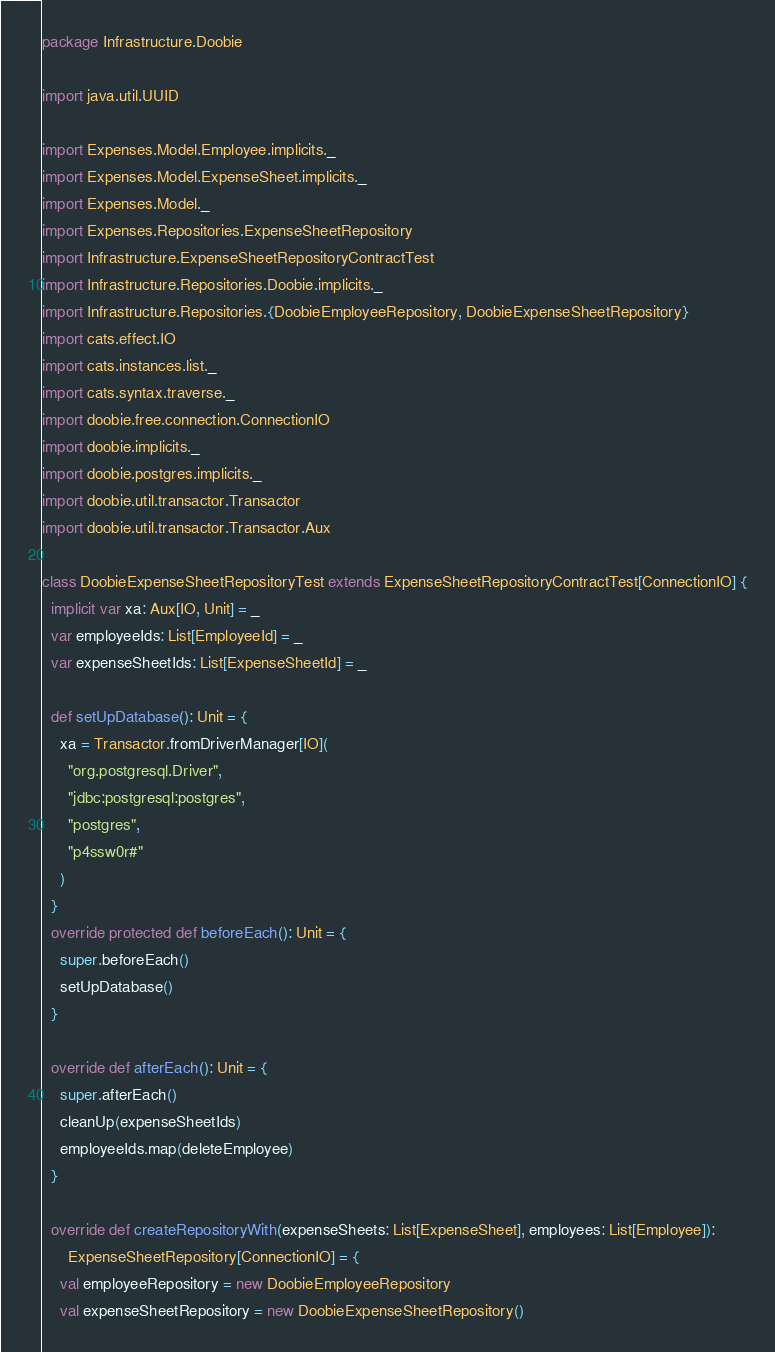<code> <loc_0><loc_0><loc_500><loc_500><_Scala_>package Infrastructure.Doobie

import java.util.UUID

import Expenses.Model.Employee.implicits._
import Expenses.Model.ExpenseSheet.implicits._
import Expenses.Model._
import Expenses.Repositories.ExpenseSheetRepository
import Infrastructure.ExpenseSheetRepositoryContractTest
import Infrastructure.Repositories.Doobie.implicits._
import Infrastructure.Repositories.{DoobieEmployeeRepository, DoobieExpenseSheetRepository}
import cats.effect.IO
import cats.instances.list._
import cats.syntax.traverse._
import doobie.free.connection.ConnectionIO
import doobie.implicits._
import doobie.postgres.implicits._
import doobie.util.transactor.Transactor
import doobie.util.transactor.Transactor.Aux

class DoobieExpenseSheetRepositoryTest extends ExpenseSheetRepositoryContractTest[ConnectionIO] {
  implicit var xa: Aux[IO, Unit] = _
  var employeeIds: List[EmployeeId] = _
  var expenseSheetIds: List[ExpenseSheetId] = _

  def setUpDatabase(): Unit = {
    xa = Transactor.fromDriverManager[IO](
      "org.postgresql.Driver",
      "jdbc:postgresql:postgres",
      "postgres",
      "p4ssw0r#"
    )
  }
  override protected def beforeEach(): Unit = {
    super.beforeEach()
    setUpDatabase()
  }

  override def afterEach(): Unit = {
    super.afterEach()
    cleanUp(expenseSheetIds)
    employeeIds.map(deleteEmployee)
  }

  override def createRepositoryWith(expenseSheets: List[ExpenseSheet], employees: List[Employee]):
      ExpenseSheetRepository[ConnectionIO] = {
    val employeeRepository = new DoobieEmployeeRepository
    val expenseSheetRepository = new DoobieExpenseSheetRepository()
</code> 